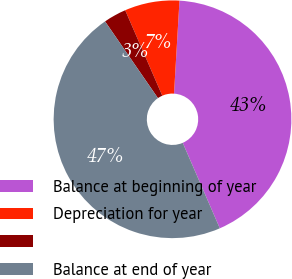Convert chart. <chart><loc_0><loc_0><loc_500><loc_500><pie_chart><fcel>Balance at beginning of year<fcel>Depreciation for year<fcel>Unnamed: 2<fcel>Balance at end of year<nl><fcel>42.55%<fcel>7.45%<fcel>3.09%<fcel>46.91%<nl></chart> 